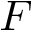Convert formula to latex. <formula><loc_0><loc_0><loc_500><loc_500>F</formula> 